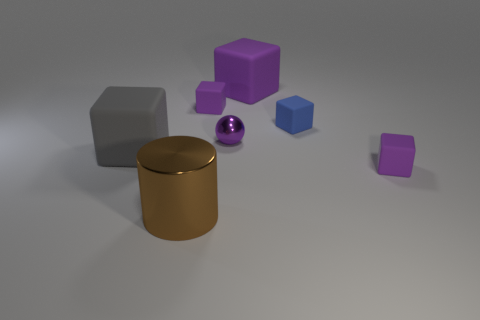Subtract all blue spheres. How many purple blocks are left? 3 Subtract all gray cubes. How many cubes are left? 4 Subtract all blue blocks. How many blocks are left? 4 Subtract all blue cubes. Subtract all red cylinders. How many cubes are left? 4 Add 3 large brown metallic objects. How many objects exist? 10 Subtract all cylinders. How many objects are left? 6 Subtract all red matte cylinders. Subtract all small spheres. How many objects are left? 6 Add 5 blue matte objects. How many blue matte objects are left? 6 Add 2 cyan balls. How many cyan balls exist? 2 Subtract 0 green spheres. How many objects are left? 7 